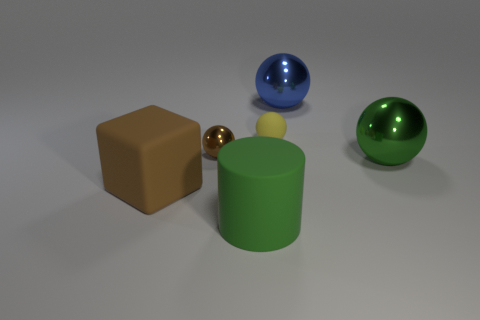What color is the big thing that is behind the small metallic sphere?
Make the answer very short. Blue. What color is the metal object that is the same size as the rubber ball?
Provide a succinct answer. Brown. Is the size of the brown rubber thing the same as the blue ball?
Give a very brief answer. Yes. There is a blue metal sphere; how many tiny shiny objects are on the left side of it?
Give a very brief answer. 1. How many objects are balls that are left of the large blue metal thing or big rubber cylinders?
Offer a very short reply. 3. Is the number of large objects behind the small yellow rubber thing greater than the number of green matte cylinders that are behind the big green cylinder?
Provide a succinct answer. Yes. What size is the sphere that is the same color as the large cube?
Keep it short and to the point. Small. There is a brown matte object; is its size the same as the green object in front of the green metallic thing?
Provide a short and direct response. Yes. How many cubes are small yellow things or metallic objects?
Your answer should be compact. 0. What is the size of the green thing that is made of the same material as the yellow ball?
Give a very brief answer. Large. 